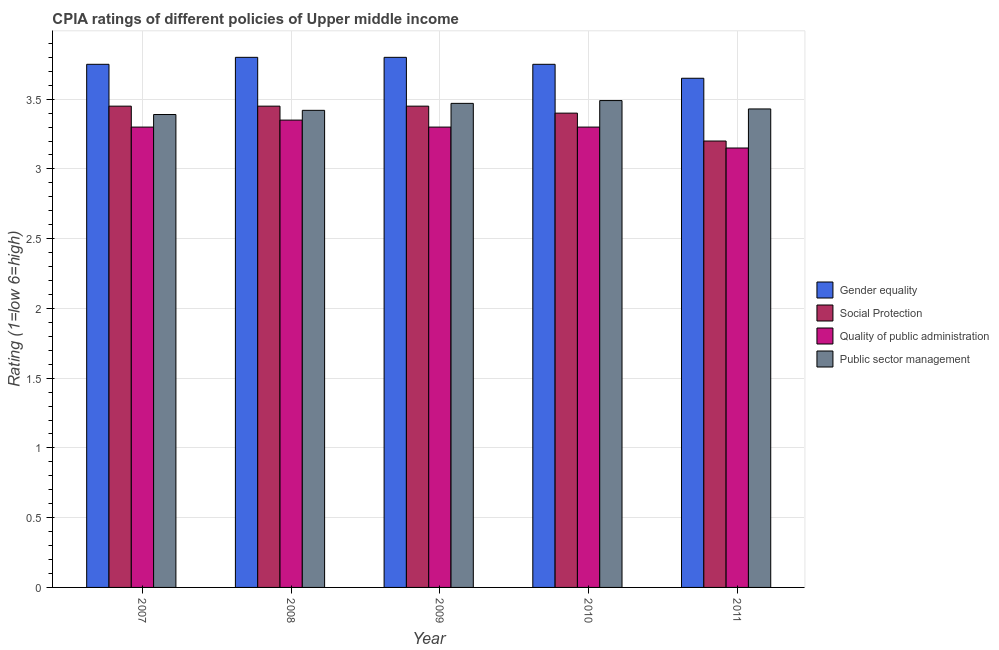How many different coloured bars are there?
Your response must be concise. 4. Are the number of bars per tick equal to the number of legend labels?
Your answer should be very brief. Yes. Are the number of bars on each tick of the X-axis equal?
Make the answer very short. Yes. Across all years, what is the maximum cpia rating of quality of public administration?
Provide a short and direct response. 3.35. Across all years, what is the minimum cpia rating of gender equality?
Make the answer very short. 3.65. In which year was the cpia rating of public sector management minimum?
Your answer should be very brief. 2007. What is the total cpia rating of gender equality in the graph?
Ensure brevity in your answer.  18.75. What is the difference between the cpia rating of gender equality in 2008 and that in 2010?
Your response must be concise. 0.05. What is the difference between the cpia rating of social protection in 2008 and the cpia rating of public sector management in 2007?
Provide a succinct answer. 0. What is the average cpia rating of quality of public administration per year?
Offer a terse response. 3.28. What is the ratio of the cpia rating of social protection in 2007 to that in 2011?
Make the answer very short. 1.08. Is the cpia rating of gender equality in 2007 less than that in 2011?
Offer a very short reply. No. What is the difference between the highest and the second highest cpia rating of social protection?
Provide a succinct answer. 0. What is the difference between the highest and the lowest cpia rating of social protection?
Keep it short and to the point. 0.25. In how many years, is the cpia rating of gender equality greater than the average cpia rating of gender equality taken over all years?
Your response must be concise. 2. What does the 1st bar from the left in 2007 represents?
Keep it short and to the point. Gender equality. What does the 4th bar from the right in 2010 represents?
Make the answer very short. Gender equality. How many years are there in the graph?
Your answer should be very brief. 5. Are the values on the major ticks of Y-axis written in scientific E-notation?
Offer a very short reply. No. What is the title of the graph?
Offer a terse response. CPIA ratings of different policies of Upper middle income. Does "International Development Association" appear as one of the legend labels in the graph?
Your response must be concise. No. What is the label or title of the X-axis?
Make the answer very short. Year. What is the Rating (1=low 6=high) of Gender equality in 2007?
Provide a succinct answer. 3.75. What is the Rating (1=low 6=high) in Social Protection in 2007?
Offer a terse response. 3.45. What is the Rating (1=low 6=high) of Public sector management in 2007?
Make the answer very short. 3.39. What is the Rating (1=low 6=high) of Social Protection in 2008?
Provide a short and direct response. 3.45. What is the Rating (1=low 6=high) of Quality of public administration in 2008?
Offer a very short reply. 3.35. What is the Rating (1=low 6=high) of Public sector management in 2008?
Give a very brief answer. 3.42. What is the Rating (1=low 6=high) in Social Protection in 2009?
Your answer should be very brief. 3.45. What is the Rating (1=low 6=high) of Quality of public administration in 2009?
Provide a short and direct response. 3.3. What is the Rating (1=low 6=high) in Public sector management in 2009?
Ensure brevity in your answer.  3.47. What is the Rating (1=low 6=high) of Gender equality in 2010?
Your answer should be very brief. 3.75. What is the Rating (1=low 6=high) in Social Protection in 2010?
Your response must be concise. 3.4. What is the Rating (1=low 6=high) of Public sector management in 2010?
Keep it short and to the point. 3.49. What is the Rating (1=low 6=high) in Gender equality in 2011?
Offer a very short reply. 3.65. What is the Rating (1=low 6=high) of Social Protection in 2011?
Keep it short and to the point. 3.2. What is the Rating (1=low 6=high) in Quality of public administration in 2011?
Provide a succinct answer. 3.15. What is the Rating (1=low 6=high) of Public sector management in 2011?
Provide a succinct answer. 3.43. Across all years, what is the maximum Rating (1=low 6=high) in Gender equality?
Ensure brevity in your answer.  3.8. Across all years, what is the maximum Rating (1=low 6=high) of Social Protection?
Make the answer very short. 3.45. Across all years, what is the maximum Rating (1=low 6=high) in Quality of public administration?
Offer a very short reply. 3.35. Across all years, what is the maximum Rating (1=low 6=high) in Public sector management?
Your answer should be compact. 3.49. Across all years, what is the minimum Rating (1=low 6=high) of Gender equality?
Provide a succinct answer. 3.65. Across all years, what is the minimum Rating (1=low 6=high) in Social Protection?
Your response must be concise. 3.2. Across all years, what is the minimum Rating (1=low 6=high) in Quality of public administration?
Your response must be concise. 3.15. Across all years, what is the minimum Rating (1=low 6=high) in Public sector management?
Give a very brief answer. 3.39. What is the total Rating (1=low 6=high) of Gender equality in the graph?
Offer a very short reply. 18.75. What is the total Rating (1=low 6=high) in Social Protection in the graph?
Make the answer very short. 16.95. What is the difference between the Rating (1=low 6=high) in Gender equality in 2007 and that in 2008?
Your response must be concise. -0.05. What is the difference between the Rating (1=low 6=high) of Public sector management in 2007 and that in 2008?
Your answer should be very brief. -0.03. What is the difference between the Rating (1=low 6=high) of Social Protection in 2007 and that in 2009?
Make the answer very short. 0. What is the difference between the Rating (1=low 6=high) of Public sector management in 2007 and that in 2009?
Your response must be concise. -0.08. What is the difference between the Rating (1=low 6=high) of Gender equality in 2007 and that in 2010?
Your answer should be compact. 0. What is the difference between the Rating (1=low 6=high) of Quality of public administration in 2007 and that in 2010?
Your answer should be compact. 0. What is the difference between the Rating (1=low 6=high) of Gender equality in 2007 and that in 2011?
Give a very brief answer. 0.1. What is the difference between the Rating (1=low 6=high) of Public sector management in 2007 and that in 2011?
Your answer should be compact. -0.04. What is the difference between the Rating (1=low 6=high) of Gender equality in 2008 and that in 2009?
Your answer should be compact. 0. What is the difference between the Rating (1=low 6=high) of Quality of public administration in 2008 and that in 2009?
Ensure brevity in your answer.  0.05. What is the difference between the Rating (1=low 6=high) of Public sector management in 2008 and that in 2010?
Ensure brevity in your answer.  -0.07. What is the difference between the Rating (1=low 6=high) of Gender equality in 2008 and that in 2011?
Keep it short and to the point. 0.15. What is the difference between the Rating (1=low 6=high) of Social Protection in 2008 and that in 2011?
Offer a very short reply. 0.25. What is the difference between the Rating (1=low 6=high) of Public sector management in 2008 and that in 2011?
Your response must be concise. -0.01. What is the difference between the Rating (1=low 6=high) of Gender equality in 2009 and that in 2010?
Make the answer very short. 0.05. What is the difference between the Rating (1=low 6=high) of Social Protection in 2009 and that in 2010?
Ensure brevity in your answer.  0.05. What is the difference between the Rating (1=low 6=high) of Public sector management in 2009 and that in 2010?
Provide a succinct answer. -0.02. What is the difference between the Rating (1=low 6=high) of Gender equality in 2009 and that in 2011?
Provide a succinct answer. 0.15. What is the difference between the Rating (1=low 6=high) in Social Protection in 2009 and that in 2011?
Your answer should be compact. 0.25. What is the difference between the Rating (1=low 6=high) of Public sector management in 2009 and that in 2011?
Offer a very short reply. 0.04. What is the difference between the Rating (1=low 6=high) of Gender equality in 2010 and that in 2011?
Keep it short and to the point. 0.1. What is the difference between the Rating (1=low 6=high) of Quality of public administration in 2010 and that in 2011?
Provide a short and direct response. 0.15. What is the difference between the Rating (1=low 6=high) of Gender equality in 2007 and the Rating (1=low 6=high) of Public sector management in 2008?
Keep it short and to the point. 0.33. What is the difference between the Rating (1=low 6=high) in Social Protection in 2007 and the Rating (1=low 6=high) in Public sector management in 2008?
Your answer should be compact. 0.03. What is the difference between the Rating (1=low 6=high) of Quality of public administration in 2007 and the Rating (1=low 6=high) of Public sector management in 2008?
Offer a very short reply. -0.12. What is the difference between the Rating (1=low 6=high) of Gender equality in 2007 and the Rating (1=low 6=high) of Social Protection in 2009?
Keep it short and to the point. 0.3. What is the difference between the Rating (1=low 6=high) of Gender equality in 2007 and the Rating (1=low 6=high) of Quality of public administration in 2009?
Your answer should be very brief. 0.45. What is the difference between the Rating (1=low 6=high) of Gender equality in 2007 and the Rating (1=low 6=high) of Public sector management in 2009?
Provide a succinct answer. 0.28. What is the difference between the Rating (1=low 6=high) of Social Protection in 2007 and the Rating (1=low 6=high) of Quality of public administration in 2009?
Provide a succinct answer. 0.15. What is the difference between the Rating (1=low 6=high) in Social Protection in 2007 and the Rating (1=low 6=high) in Public sector management in 2009?
Give a very brief answer. -0.02. What is the difference between the Rating (1=low 6=high) of Quality of public administration in 2007 and the Rating (1=low 6=high) of Public sector management in 2009?
Ensure brevity in your answer.  -0.17. What is the difference between the Rating (1=low 6=high) in Gender equality in 2007 and the Rating (1=low 6=high) in Social Protection in 2010?
Make the answer very short. 0.35. What is the difference between the Rating (1=low 6=high) in Gender equality in 2007 and the Rating (1=low 6=high) in Quality of public administration in 2010?
Give a very brief answer. 0.45. What is the difference between the Rating (1=low 6=high) in Gender equality in 2007 and the Rating (1=low 6=high) in Public sector management in 2010?
Give a very brief answer. 0.26. What is the difference between the Rating (1=low 6=high) in Social Protection in 2007 and the Rating (1=low 6=high) in Public sector management in 2010?
Provide a succinct answer. -0.04. What is the difference between the Rating (1=low 6=high) in Quality of public administration in 2007 and the Rating (1=low 6=high) in Public sector management in 2010?
Keep it short and to the point. -0.19. What is the difference between the Rating (1=low 6=high) in Gender equality in 2007 and the Rating (1=low 6=high) in Social Protection in 2011?
Offer a very short reply. 0.55. What is the difference between the Rating (1=low 6=high) of Gender equality in 2007 and the Rating (1=low 6=high) of Public sector management in 2011?
Provide a short and direct response. 0.32. What is the difference between the Rating (1=low 6=high) in Social Protection in 2007 and the Rating (1=low 6=high) in Quality of public administration in 2011?
Keep it short and to the point. 0.3. What is the difference between the Rating (1=low 6=high) of Quality of public administration in 2007 and the Rating (1=low 6=high) of Public sector management in 2011?
Your answer should be compact. -0.13. What is the difference between the Rating (1=low 6=high) of Gender equality in 2008 and the Rating (1=low 6=high) of Quality of public administration in 2009?
Give a very brief answer. 0.5. What is the difference between the Rating (1=low 6=high) of Gender equality in 2008 and the Rating (1=low 6=high) of Public sector management in 2009?
Offer a very short reply. 0.33. What is the difference between the Rating (1=low 6=high) of Social Protection in 2008 and the Rating (1=low 6=high) of Public sector management in 2009?
Keep it short and to the point. -0.02. What is the difference between the Rating (1=low 6=high) of Quality of public administration in 2008 and the Rating (1=low 6=high) of Public sector management in 2009?
Your answer should be compact. -0.12. What is the difference between the Rating (1=low 6=high) of Gender equality in 2008 and the Rating (1=low 6=high) of Public sector management in 2010?
Offer a very short reply. 0.31. What is the difference between the Rating (1=low 6=high) of Social Protection in 2008 and the Rating (1=low 6=high) of Quality of public administration in 2010?
Provide a succinct answer. 0.15. What is the difference between the Rating (1=low 6=high) of Social Protection in 2008 and the Rating (1=low 6=high) of Public sector management in 2010?
Provide a succinct answer. -0.04. What is the difference between the Rating (1=low 6=high) of Quality of public administration in 2008 and the Rating (1=low 6=high) of Public sector management in 2010?
Provide a short and direct response. -0.14. What is the difference between the Rating (1=low 6=high) in Gender equality in 2008 and the Rating (1=low 6=high) in Social Protection in 2011?
Offer a terse response. 0.6. What is the difference between the Rating (1=low 6=high) in Gender equality in 2008 and the Rating (1=low 6=high) in Quality of public administration in 2011?
Ensure brevity in your answer.  0.65. What is the difference between the Rating (1=low 6=high) in Gender equality in 2008 and the Rating (1=low 6=high) in Public sector management in 2011?
Your response must be concise. 0.37. What is the difference between the Rating (1=low 6=high) in Quality of public administration in 2008 and the Rating (1=low 6=high) in Public sector management in 2011?
Your answer should be very brief. -0.08. What is the difference between the Rating (1=low 6=high) in Gender equality in 2009 and the Rating (1=low 6=high) in Social Protection in 2010?
Your response must be concise. 0.4. What is the difference between the Rating (1=low 6=high) of Gender equality in 2009 and the Rating (1=low 6=high) of Quality of public administration in 2010?
Make the answer very short. 0.5. What is the difference between the Rating (1=low 6=high) of Gender equality in 2009 and the Rating (1=low 6=high) of Public sector management in 2010?
Your answer should be very brief. 0.31. What is the difference between the Rating (1=low 6=high) in Social Protection in 2009 and the Rating (1=low 6=high) in Quality of public administration in 2010?
Offer a very short reply. 0.15. What is the difference between the Rating (1=low 6=high) in Social Protection in 2009 and the Rating (1=low 6=high) in Public sector management in 2010?
Your answer should be compact. -0.04. What is the difference between the Rating (1=low 6=high) in Quality of public administration in 2009 and the Rating (1=low 6=high) in Public sector management in 2010?
Provide a succinct answer. -0.19. What is the difference between the Rating (1=low 6=high) in Gender equality in 2009 and the Rating (1=low 6=high) in Quality of public administration in 2011?
Keep it short and to the point. 0.65. What is the difference between the Rating (1=low 6=high) in Gender equality in 2009 and the Rating (1=low 6=high) in Public sector management in 2011?
Your answer should be compact. 0.37. What is the difference between the Rating (1=low 6=high) of Quality of public administration in 2009 and the Rating (1=low 6=high) of Public sector management in 2011?
Your answer should be compact. -0.13. What is the difference between the Rating (1=low 6=high) of Gender equality in 2010 and the Rating (1=low 6=high) of Social Protection in 2011?
Provide a short and direct response. 0.55. What is the difference between the Rating (1=low 6=high) of Gender equality in 2010 and the Rating (1=low 6=high) of Public sector management in 2011?
Provide a short and direct response. 0.32. What is the difference between the Rating (1=low 6=high) of Social Protection in 2010 and the Rating (1=low 6=high) of Quality of public administration in 2011?
Provide a short and direct response. 0.25. What is the difference between the Rating (1=low 6=high) in Social Protection in 2010 and the Rating (1=low 6=high) in Public sector management in 2011?
Provide a succinct answer. -0.03. What is the difference between the Rating (1=low 6=high) of Quality of public administration in 2010 and the Rating (1=low 6=high) of Public sector management in 2011?
Offer a very short reply. -0.13. What is the average Rating (1=low 6=high) of Gender equality per year?
Ensure brevity in your answer.  3.75. What is the average Rating (1=low 6=high) in Social Protection per year?
Ensure brevity in your answer.  3.39. What is the average Rating (1=low 6=high) of Quality of public administration per year?
Your answer should be compact. 3.28. What is the average Rating (1=low 6=high) in Public sector management per year?
Your answer should be compact. 3.44. In the year 2007, what is the difference between the Rating (1=low 6=high) of Gender equality and Rating (1=low 6=high) of Quality of public administration?
Make the answer very short. 0.45. In the year 2007, what is the difference between the Rating (1=low 6=high) of Gender equality and Rating (1=low 6=high) of Public sector management?
Give a very brief answer. 0.36. In the year 2007, what is the difference between the Rating (1=low 6=high) of Quality of public administration and Rating (1=low 6=high) of Public sector management?
Offer a terse response. -0.09. In the year 2008, what is the difference between the Rating (1=low 6=high) of Gender equality and Rating (1=low 6=high) of Quality of public administration?
Make the answer very short. 0.45. In the year 2008, what is the difference between the Rating (1=low 6=high) in Gender equality and Rating (1=low 6=high) in Public sector management?
Your response must be concise. 0.38. In the year 2008, what is the difference between the Rating (1=low 6=high) in Quality of public administration and Rating (1=low 6=high) in Public sector management?
Your answer should be very brief. -0.07. In the year 2009, what is the difference between the Rating (1=low 6=high) of Gender equality and Rating (1=low 6=high) of Public sector management?
Your answer should be compact. 0.33. In the year 2009, what is the difference between the Rating (1=low 6=high) of Social Protection and Rating (1=low 6=high) of Quality of public administration?
Provide a short and direct response. 0.15. In the year 2009, what is the difference between the Rating (1=low 6=high) in Social Protection and Rating (1=low 6=high) in Public sector management?
Offer a terse response. -0.02. In the year 2009, what is the difference between the Rating (1=low 6=high) in Quality of public administration and Rating (1=low 6=high) in Public sector management?
Provide a succinct answer. -0.17. In the year 2010, what is the difference between the Rating (1=low 6=high) in Gender equality and Rating (1=low 6=high) in Social Protection?
Make the answer very short. 0.35. In the year 2010, what is the difference between the Rating (1=low 6=high) of Gender equality and Rating (1=low 6=high) of Quality of public administration?
Offer a terse response. 0.45. In the year 2010, what is the difference between the Rating (1=low 6=high) in Gender equality and Rating (1=low 6=high) in Public sector management?
Your response must be concise. 0.26. In the year 2010, what is the difference between the Rating (1=low 6=high) of Social Protection and Rating (1=low 6=high) of Public sector management?
Provide a succinct answer. -0.09. In the year 2010, what is the difference between the Rating (1=low 6=high) of Quality of public administration and Rating (1=low 6=high) of Public sector management?
Provide a short and direct response. -0.19. In the year 2011, what is the difference between the Rating (1=low 6=high) in Gender equality and Rating (1=low 6=high) in Social Protection?
Keep it short and to the point. 0.45. In the year 2011, what is the difference between the Rating (1=low 6=high) of Gender equality and Rating (1=low 6=high) of Quality of public administration?
Make the answer very short. 0.5. In the year 2011, what is the difference between the Rating (1=low 6=high) of Gender equality and Rating (1=low 6=high) of Public sector management?
Ensure brevity in your answer.  0.22. In the year 2011, what is the difference between the Rating (1=low 6=high) of Social Protection and Rating (1=low 6=high) of Quality of public administration?
Your response must be concise. 0.05. In the year 2011, what is the difference between the Rating (1=low 6=high) of Social Protection and Rating (1=low 6=high) of Public sector management?
Your answer should be compact. -0.23. In the year 2011, what is the difference between the Rating (1=low 6=high) of Quality of public administration and Rating (1=low 6=high) of Public sector management?
Your answer should be compact. -0.28. What is the ratio of the Rating (1=low 6=high) in Gender equality in 2007 to that in 2008?
Offer a very short reply. 0.99. What is the ratio of the Rating (1=low 6=high) of Quality of public administration in 2007 to that in 2008?
Give a very brief answer. 0.99. What is the ratio of the Rating (1=low 6=high) in Quality of public administration in 2007 to that in 2009?
Make the answer very short. 1. What is the ratio of the Rating (1=low 6=high) in Public sector management in 2007 to that in 2009?
Provide a succinct answer. 0.98. What is the ratio of the Rating (1=low 6=high) of Social Protection in 2007 to that in 2010?
Provide a short and direct response. 1.01. What is the ratio of the Rating (1=low 6=high) of Public sector management in 2007 to that in 2010?
Offer a terse response. 0.97. What is the ratio of the Rating (1=low 6=high) of Gender equality in 2007 to that in 2011?
Your answer should be very brief. 1.03. What is the ratio of the Rating (1=low 6=high) of Social Protection in 2007 to that in 2011?
Your answer should be compact. 1.08. What is the ratio of the Rating (1=low 6=high) of Quality of public administration in 2007 to that in 2011?
Offer a terse response. 1.05. What is the ratio of the Rating (1=low 6=high) in Public sector management in 2007 to that in 2011?
Offer a very short reply. 0.99. What is the ratio of the Rating (1=low 6=high) of Gender equality in 2008 to that in 2009?
Provide a short and direct response. 1. What is the ratio of the Rating (1=low 6=high) of Quality of public administration in 2008 to that in 2009?
Ensure brevity in your answer.  1.02. What is the ratio of the Rating (1=low 6=high) in Public sector management in 2008 to that in 2009?
Give a very brief answer. 0.99. What is the ratio of the Rating (1=low 6=high) of Gender equality in 2008 to that in 2010?
Keep it short and to the point. 1.01. What is the ratio of the Rating (1=low 6=high) in Social Protection in 2008 to that in 2010?
Your response must be concise. 1.01. What is the ratio of the Rating (1=low 6=high) of Quality of public administration in 2008 to that in 2010?
Make the answer very short. 1.02. What is the ratio of the Rating (1=low 6=high) in Public sector management in 2008 to that in 2010?
Your answer should be very brief. 0.98. What is the ratio of the Rating (1=low 6=high) in Gender equality in 2008 to that in 2011?
Offer a very short reply. 1.04. What is the ratio of the Rating (1=low 6=high) in Social Protection in 2008 to that in 2011?
Make the answer very short. 1.08. What is the ratio of the Rating (1=low 6=high) in Quality of public administration in 2008 to that in 2011?
Provide a succinct answer. 1.06. What is the ratio of the Rating (1=low 6=high) of Gender equality in 2009 to that in 2010?
Make the answer very short. 1.01. What is the ratio of the Rating (1=low 6=high) of Social Protection in 2009 to that in 2010?
Offer a very short reply. 1.01. What is the ratio of the Rating (1=low 6=high) of Public sector management in 2009 to that in 2010?
Make the answer very short. 0.99. What is the ratio of the Rating (1=low 6=high) of Gender equality in 2009 to that in 2011?
Make the answer very short. 1.04. What is the ratio of the Rating (1=low 6=high) of Social Protection in 2009 to that in 2011?
Make the answer very short. 1.08. What is the ratio of the Rating (1=low 6=high) of Quality of public administration in 2009 to that in 2011?
Give a very brief answer. 1.05. What is the ratio of the Rating (1=low 6=high) of Public sector management in 2009 to that in 2011?
Offer a very short reply. 1.01. What is the ratio of the Rating (1=low 6=high) of Gender equality in 2010 to that in 2011?
Your answer should be compact. 1.03. What is the ratio of the Rating (1=low 6=high) of Quality of public administration in 2010 to that in 2011?
Your answer should be compact. 1.05. What is the ratio of the Rating (1=low 6=high) in Public sector management in 2010 to that in 2011?
Your response must be concise. 1.02. What is the difference between the highest and the second highest Rating (1=low 6=high) in Social Protection?
Give a very brief answer. 0. What is the difference between the highest and the second highest Rating (1=low 6=high) in Public sector management?
Keep it short and to the point. 0.02. What is the difference between the highest and the lowest Rating (1=low 6=high) in Quality of public administration?
Your answer should be very brief. 0.2. 